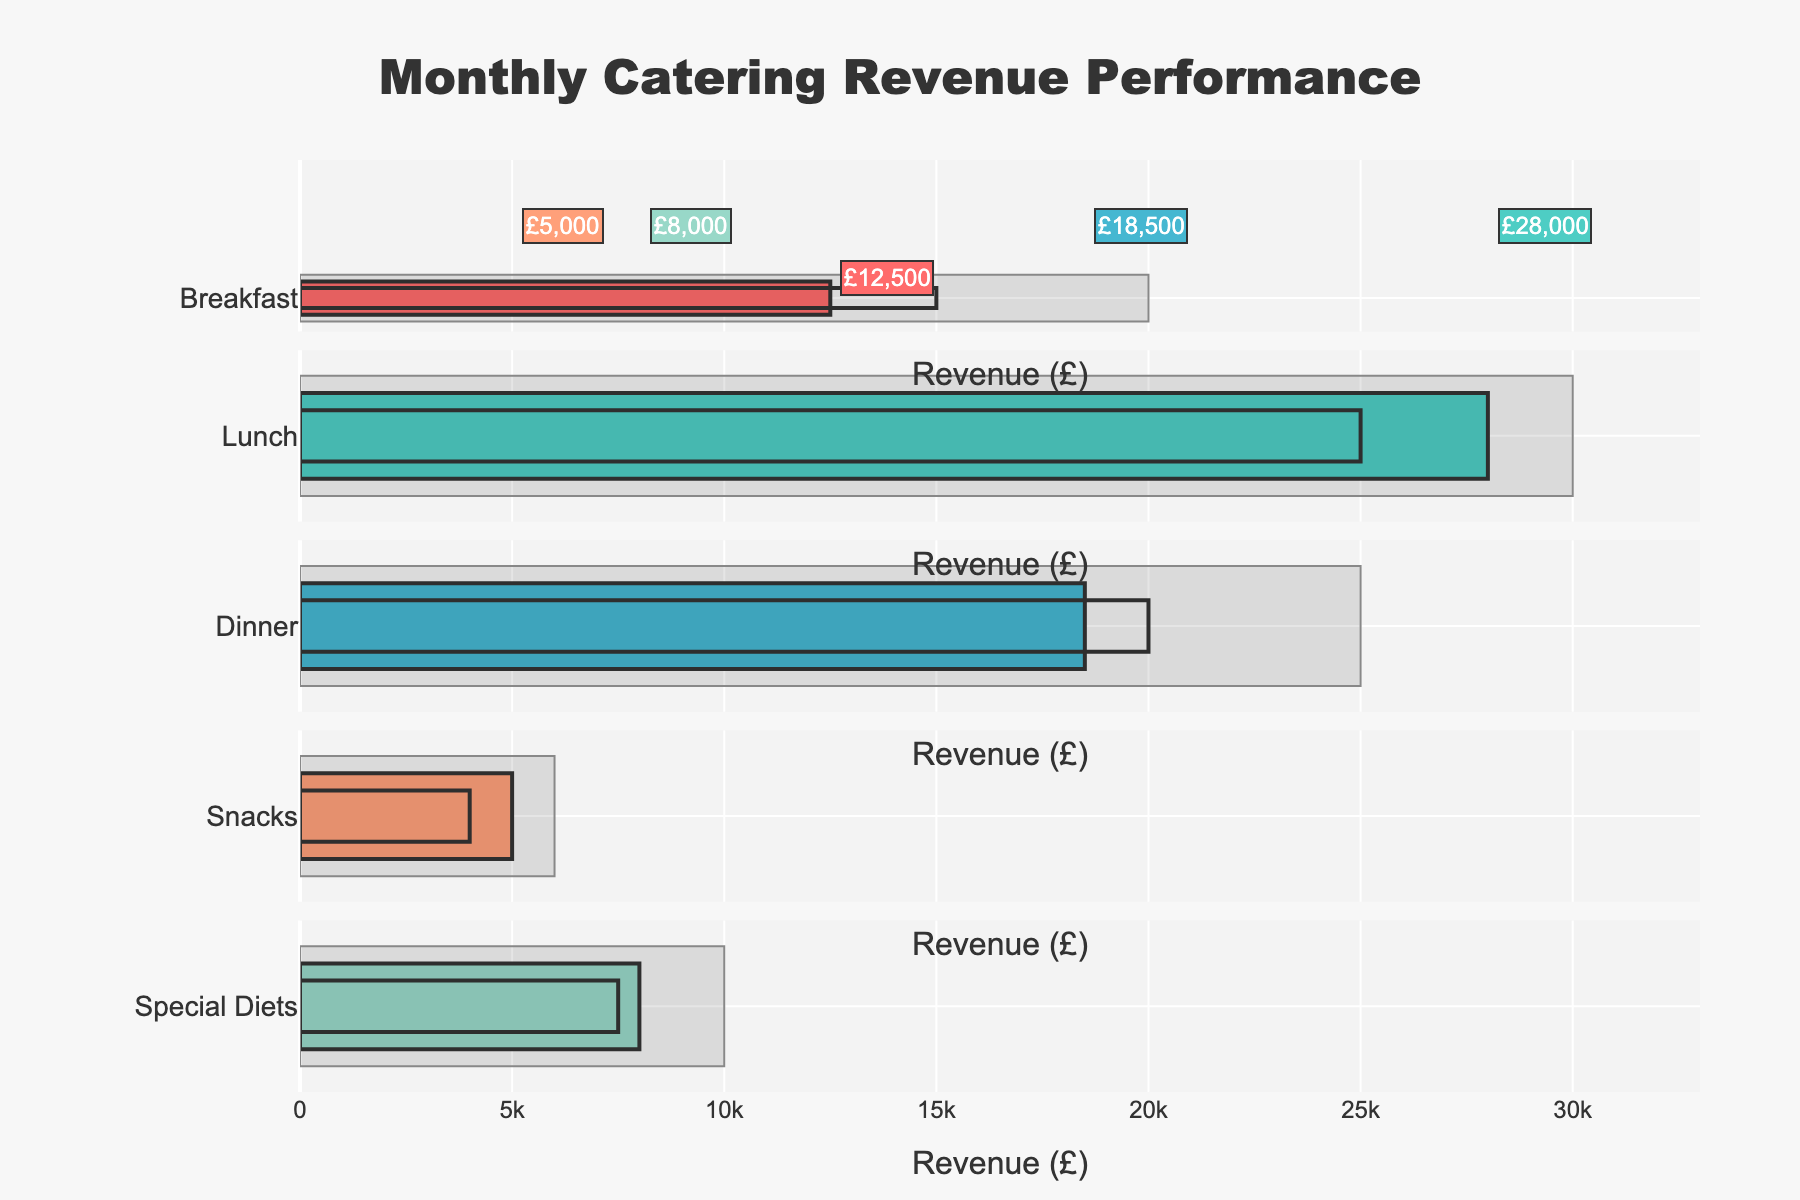What is the title of the figure? The title is displayed at the top of the chart in large font. It provides a summary description of what the chart represents.
Answer: Monthly Catering Revenue Performance What is the actual revenue for breakfast? Check the bar labeled "Breakfast" and read the annotation over the colored bar for the actual revenue.
Answer: £12,500 Which meal type has the highest actual revenue? Compare the lengths of all the bars representing actual revenue and identify the longest one.
Answer: Lunch Did snacks meet their target revenue? Compare the actual revenue bar (colored) for snacks with the target revenue bar (transparent).
Answer: Yes How much more than the target revenue did lunch achieve? Subtract lunch’s target revenue from its actual revenue by looking at the respective bar lengths.
Answer: £3,000 Which meal type is furthest from meeting its target revenue? Determine the maximum difference between target and actual revenue by comparing the gaps across all meals.
Answer: Dinner What is the total actual revenue for all meal types combined? Add together all the actual revenue amounts shown by the colored bars.
Answer: £72,000 Between dinner and snacks, which one exceeded its maximum revenue more, if any? Compare the actual revenue bars of dinner and snacks with their maximum revenue bars and see which one (if any) surpassed it more.
Answer: Neither How much lower is the actual revenue compared to the maximum revenue for breakfast? Subtract breakfast’s actual revenue from its maximum revenue by looking at breakfast's bar lengths.
Answer: £7,500 Which meal type has the smallest gap between actual revenue and maximum revenue? Compare each meal's actual and maximum revenue bars and find the smallest difference.
Answer: Special Diets 